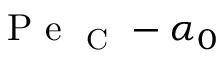Convert formula to latex. <formula><loc_0><loc_0><loc_500><loc_500>P e _ { C } - \alpha _ { 0 }</formula> 